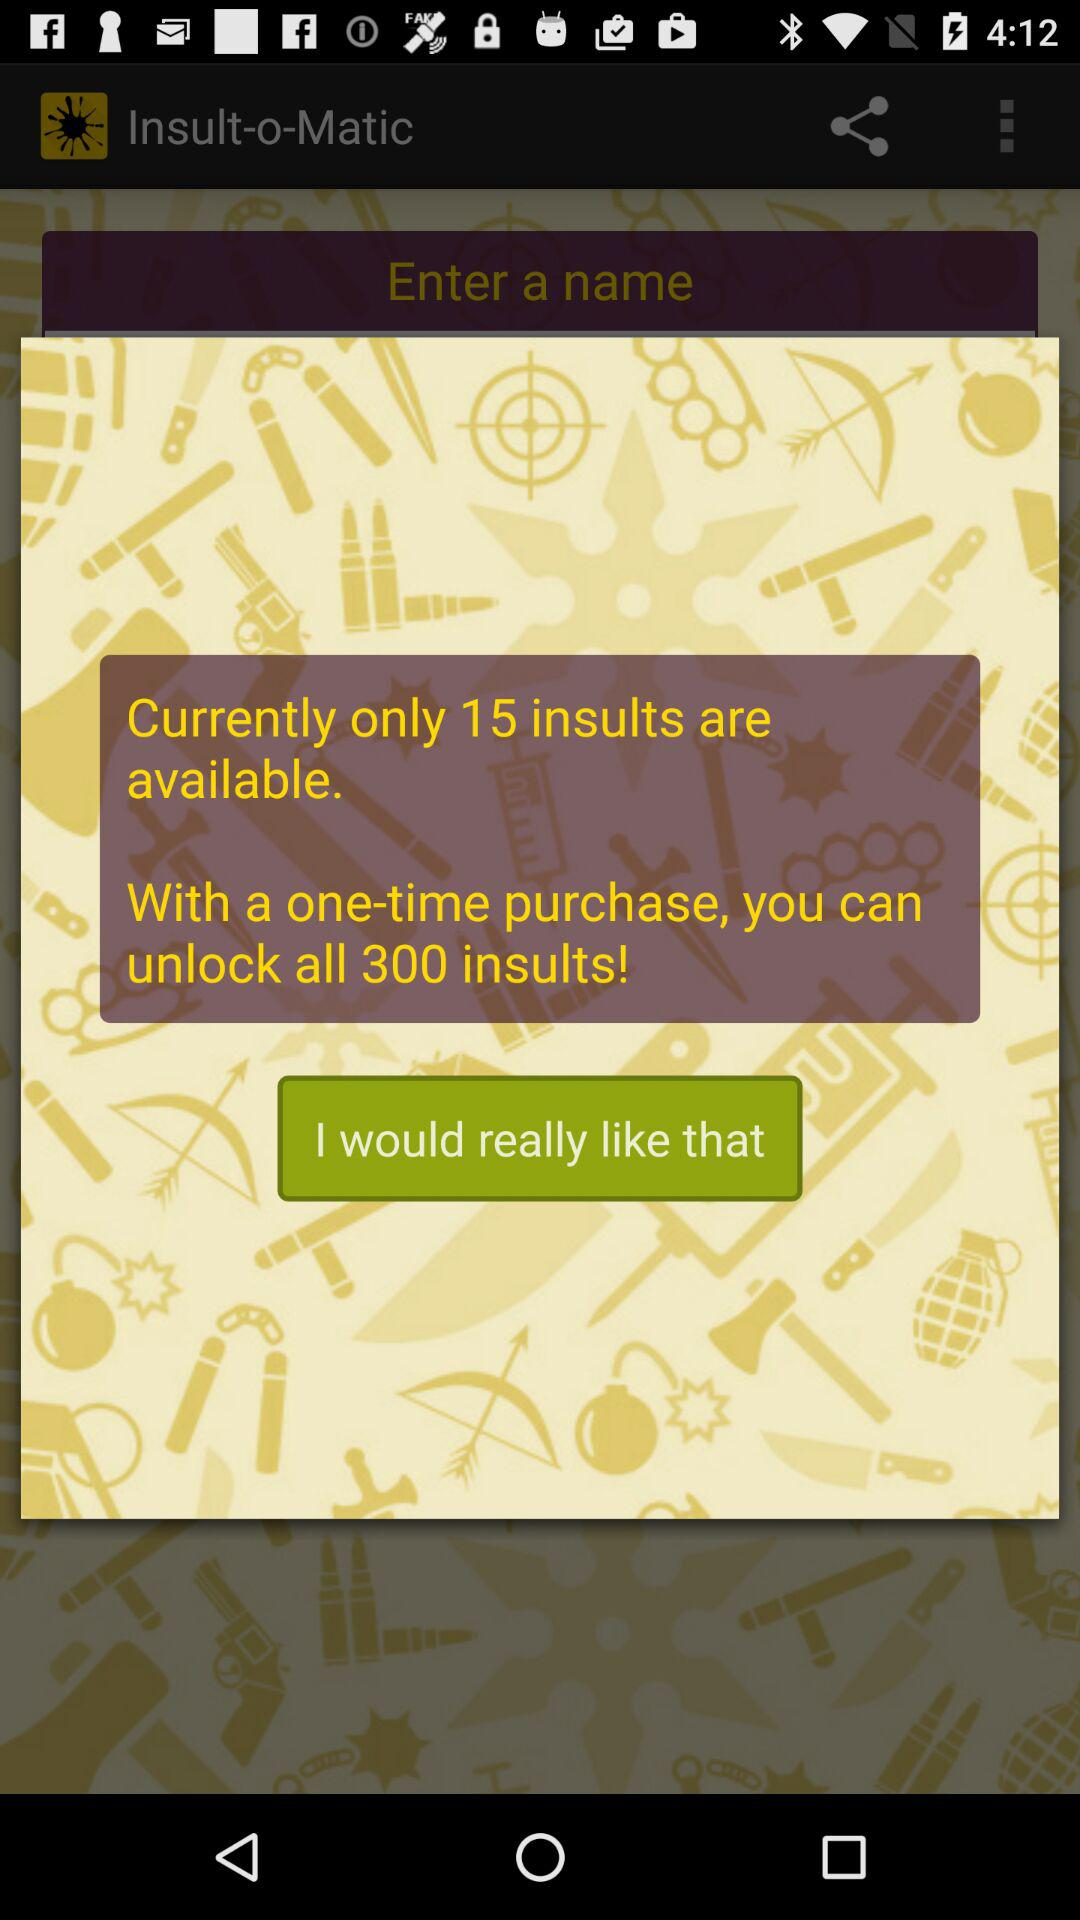How many insults are available? There are only 15 insults available. 